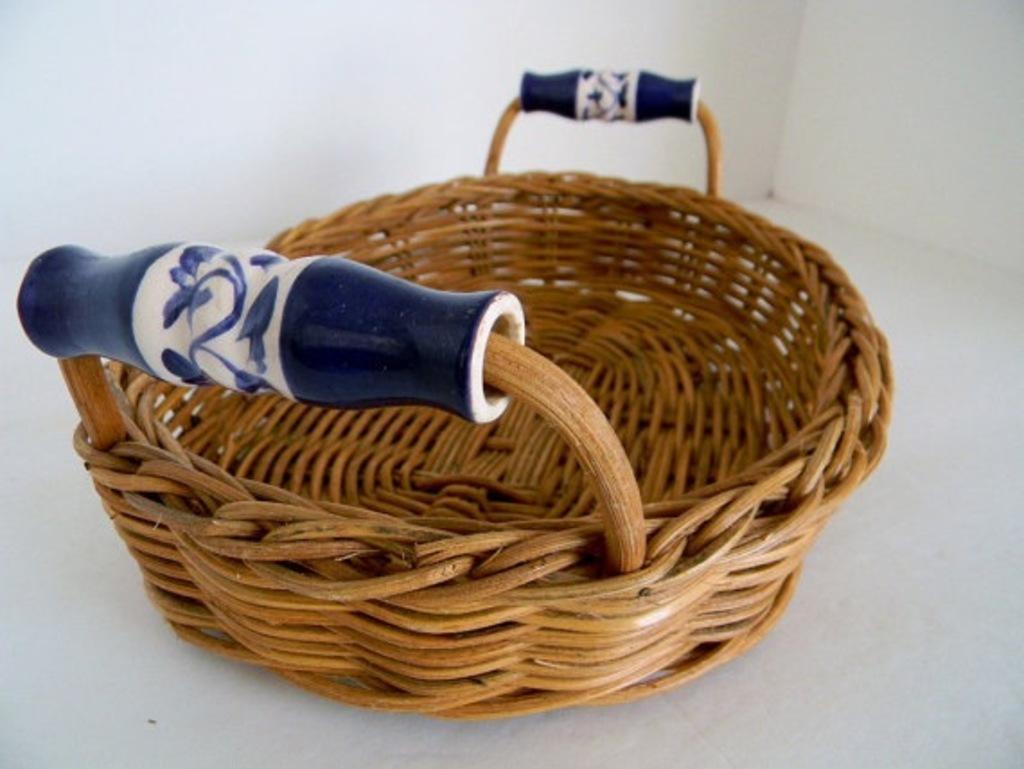Could you give a brief overview of what you see in this image? In this image there is a wooden basket, at the top may be there is the wall. 